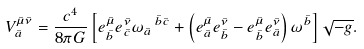Convert formula to latex. <formula><loc_0><loc_0><loc_500><loc_500>V ^ { \bar { \mu } \bar { \nu } } _ { \bar { a } } = \frac { c ^ { 4 } } { 8 \pi G } \left [ e ^ { \bar { \mu } } _ { \bar { b } } e ^ { \bar { \nu } } _ { \bar { c } } \omega _ { \bar { a } } \, ^ { \bar { b } \bar { c } } + \left ( e ^ { \bar { \mu } } _ { \bar { a } } e ^ { \bar { \nu } } _ { \bar { b } } - e ^ { \bar { \mu } } _ { \bar { b } } e ^ { \bar { \nu } } _ { \bar { a } } \right ) \omega ^ { \bar { b } } \right ] \sqrt { - g } .</formula> 